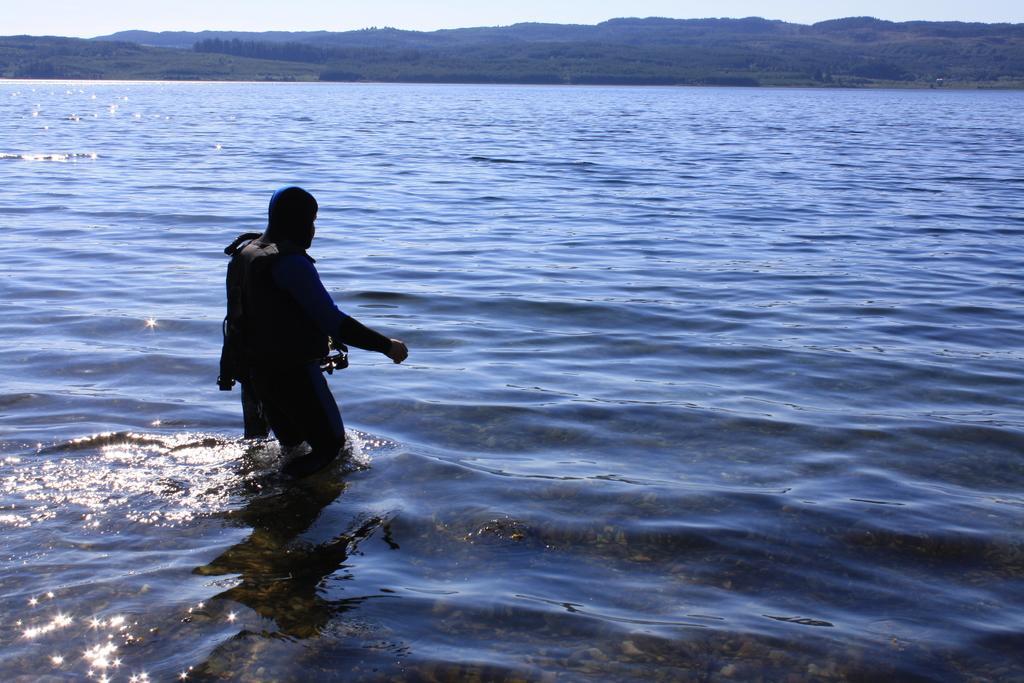Please provide a concise description of this image. This picture is clicked outside the city. On the left we can see a person is in the water body. In the background we can see the sky, trees, hills and some other objects. 